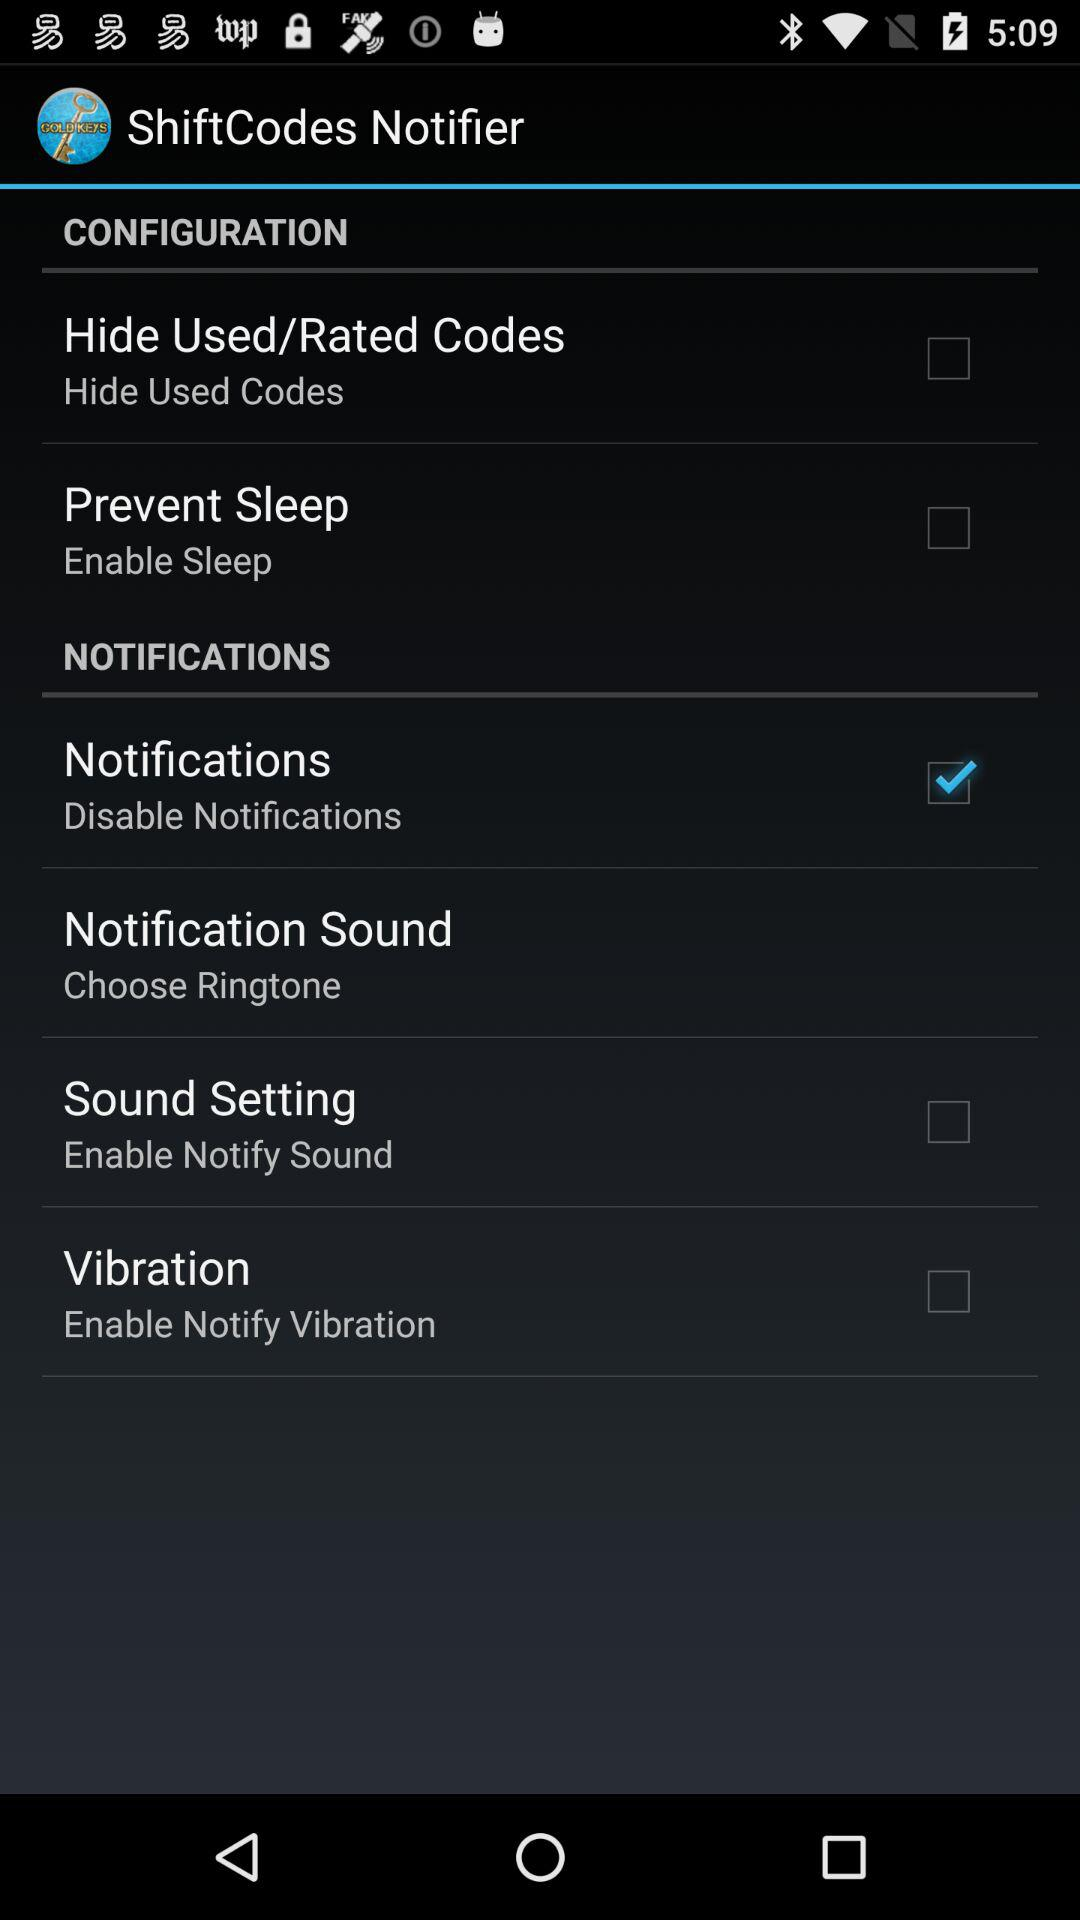Which ringtone is selected?
When the provided information is insufficient, respond with <no answer>. <no answer> 